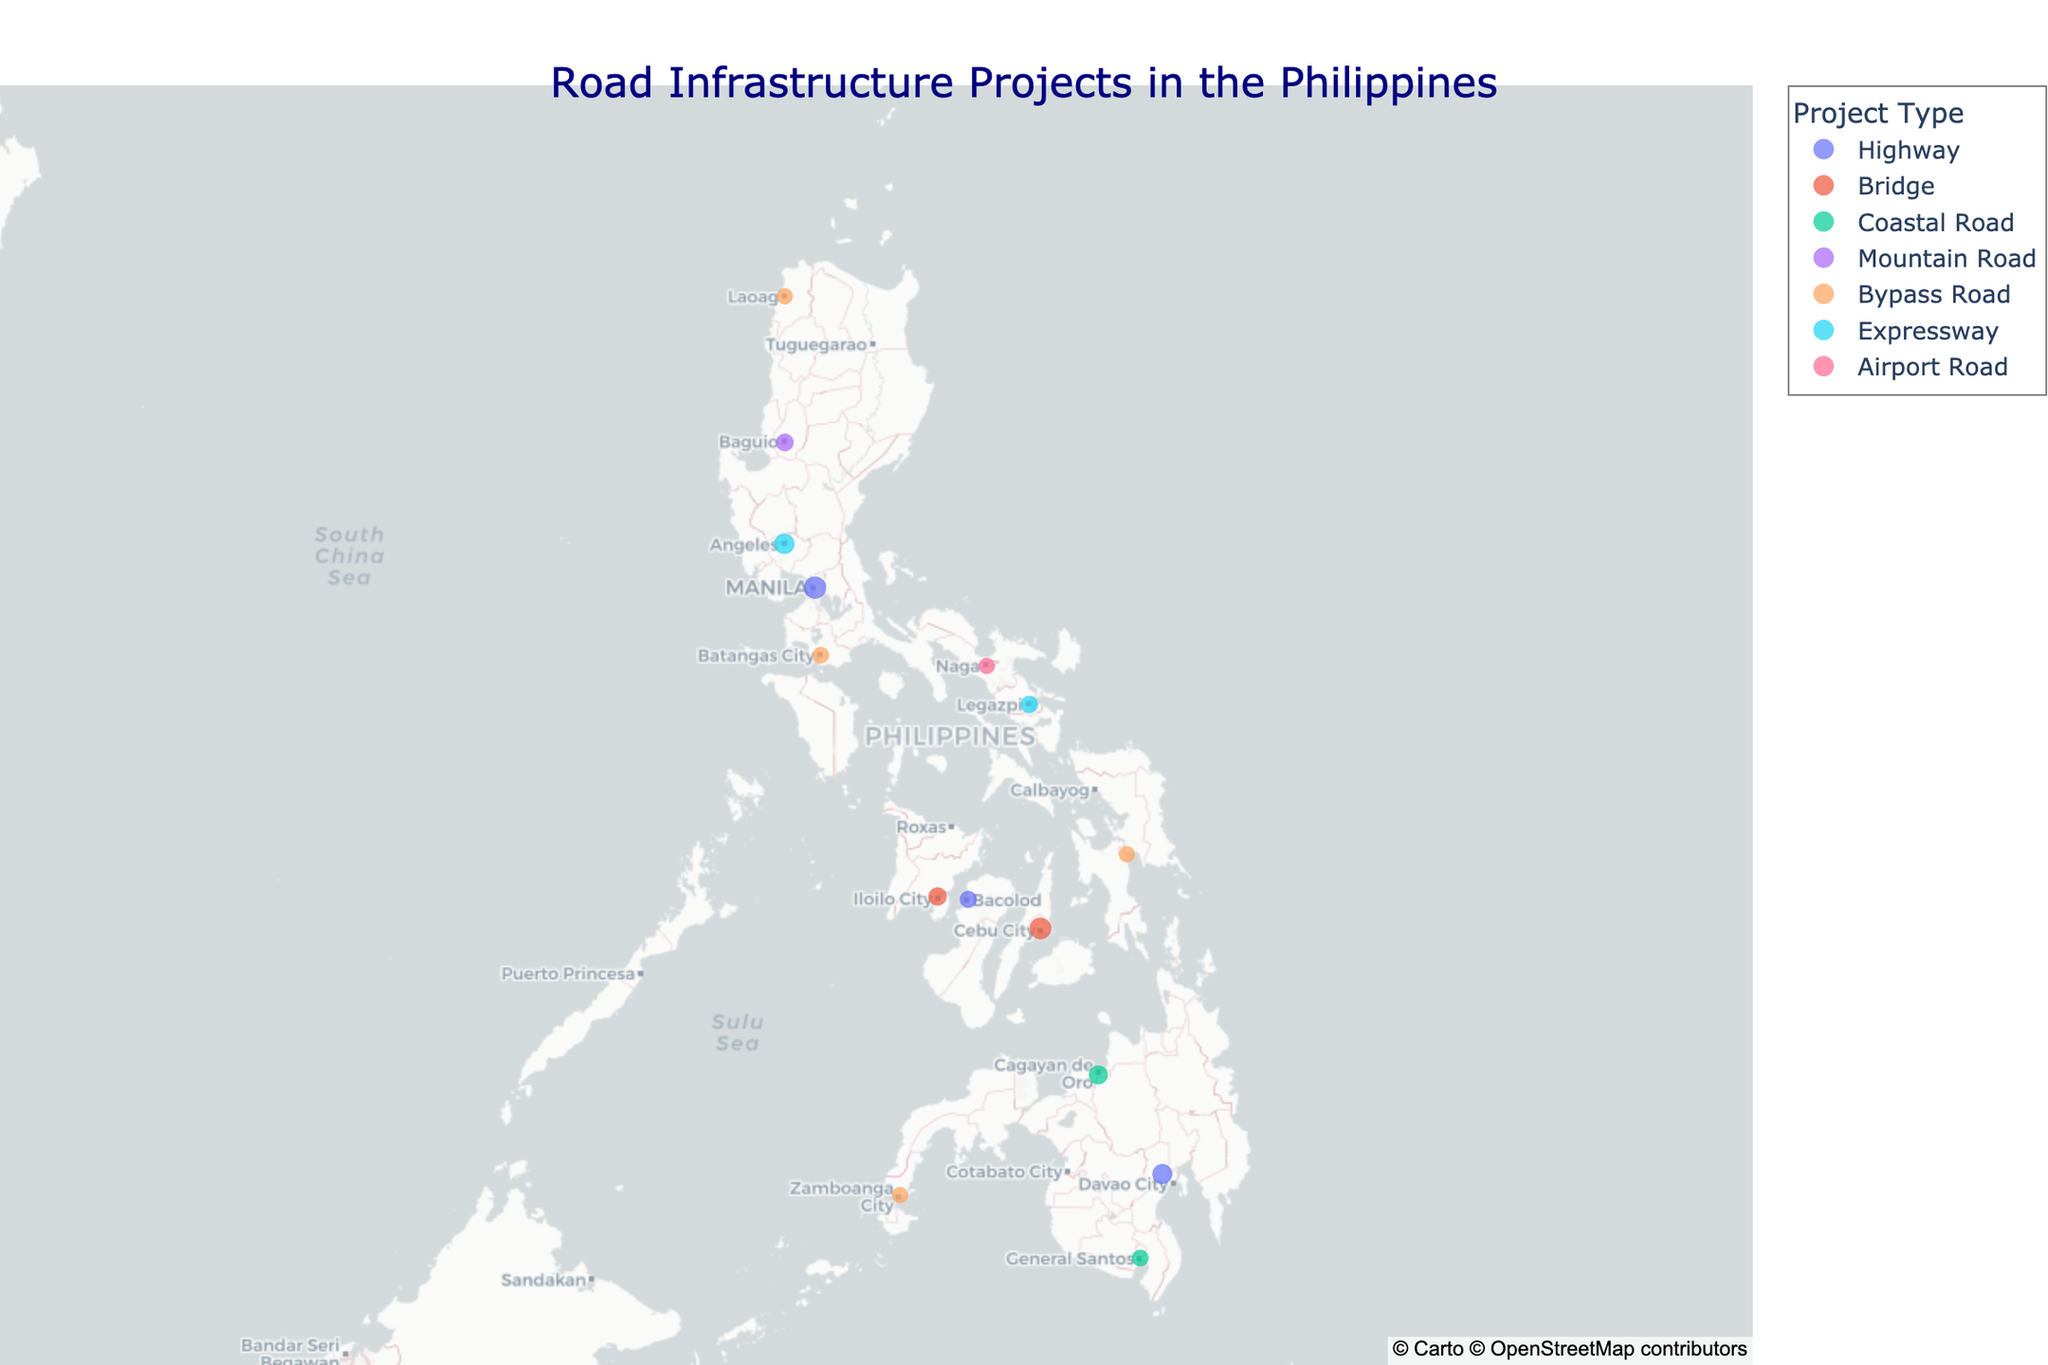What's the title of the plot? The title of the plot is located at the top and is often used to give an overview of the data being displayed.
Answer: Road Infrastructure Projects in the Philippines How many projects are categorized as highways? Count the number of data points that have the project type "Highway." There are three such points: NLEX-SLEX Connector Road, Davao City Bypass Construction Project, and Bacolod Economic Highway.
Answer: 3 Which project has the highest density score, and what is that score? Identify the project with the largest sized marker and check its hover-text for the density score. The NLEX-SLEX Connector Road in Metro Manila has the largest size marker indicating a density score of 9.2.
Answer: NLEX-SLEX Connector Road, 9.2 What is the average density score of the projects in the Visayas region (Cebu and Iloilo)? List the density scores for the Visayas region: Cebu-Cordova Link Expressway (8.7) and Iloilo-Guimaras Bridge (6.3). Calculate the average: (8.7 + 6.3) / 2 = 7.5.
Answer: 7.5 Which region has the largest number of ongoing construction projects? Count the number of distinct data points for each region. Most regions have one project each, with no one region having more than one project. Hence, multiple regions tie in this category.
Answer: Tie (All regions have 1 project each) How does the density score of the Zamboanga City Diversion Road compare to the General Santos Coastal Road? Look at the density scores: Zamboanga City Diversion Road (4.8) and General Santos Coastal Road (5.3). General Santos Coastal Road has a higher score compared to Zamboanga City Diversion Road.
Answer: General Santos Coastal Road is higher What's the total density score for all projects categorized as "Bypass Road"? Add the density scores of projects under the category "Bypass Road": Zamboanga City Diversion Road (4.8), Batangas City Diversion Road (5.2), Laoag City Bypass Road (4.1), and Tacloban City Bypass Road (4.9). The total is 4.8 + 5.2 + 4.1 + 4.9 = 19.
Answer: 19 Which project is the northernmost? Identify the project with the highest latitude value, which is Laoag City Bypass Road in Laoag.
Answer: Laoag City Bypass Road Among the bridge projects (Cebu-Cordova Link Expressway and Iloilo-Guimaras Bridge), which one has a higher density score? Compare the density scores of bridge projects: Cebu-Cordova Link Expressway (8.7) and Iloilo-Guimaras Bridge (6.3). The Cebu-Cordova Link Expressway has the higher density score.
Answer: Cebu-Cordova Link Expressway Are there more projects categorized as "Coastal Road" or "Bypass Road"? Count the data points for each category: "Coastal Road" (2) and "Bypass Road" (4). Bypass Road has more projects.
Answer: Bypass Road 